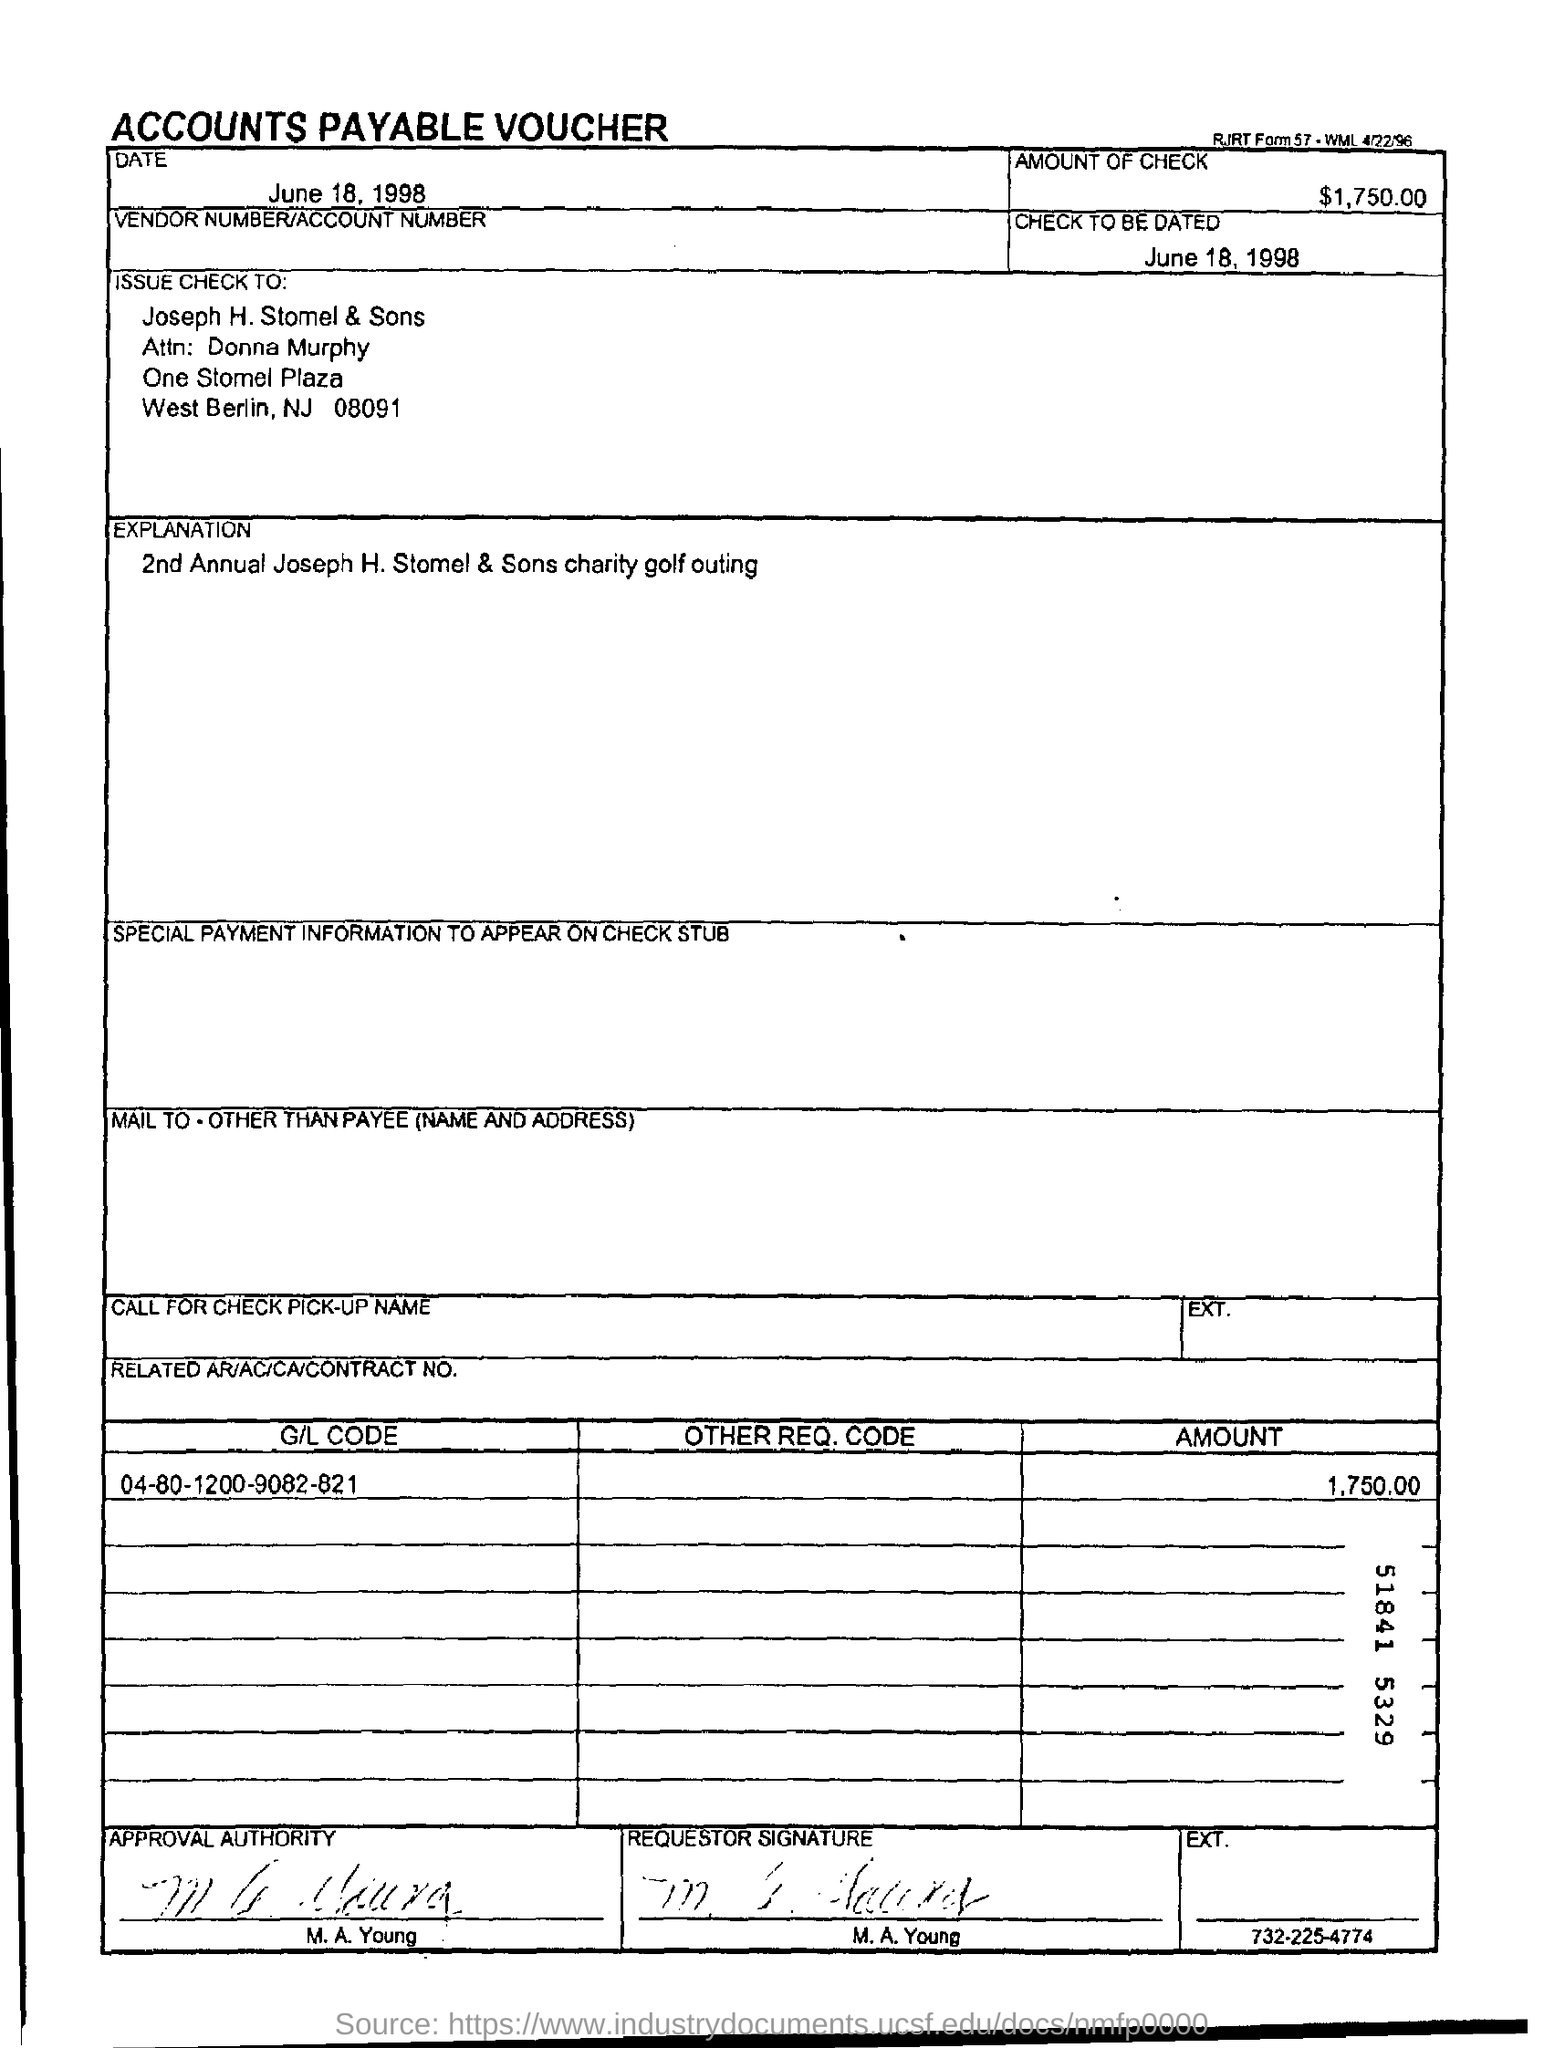Draw attention to some important aspects in this diagram. The check is being issued in the name of Joseph H. Stomel & Sons. The G/L code mentioned in the voucher is 04-80-1200-9082-821. This is an accounts payable voucher. The voucher indicates that the date mentioned is June 18, 1998. The voucher states that the amount to be checked is $1,750.00. 